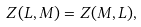Convert formula to latex. <formula><loc_0><loc_0><loc_500><loc_500>Z ( L , M ) = Z ( M , L ) ,</formula> 